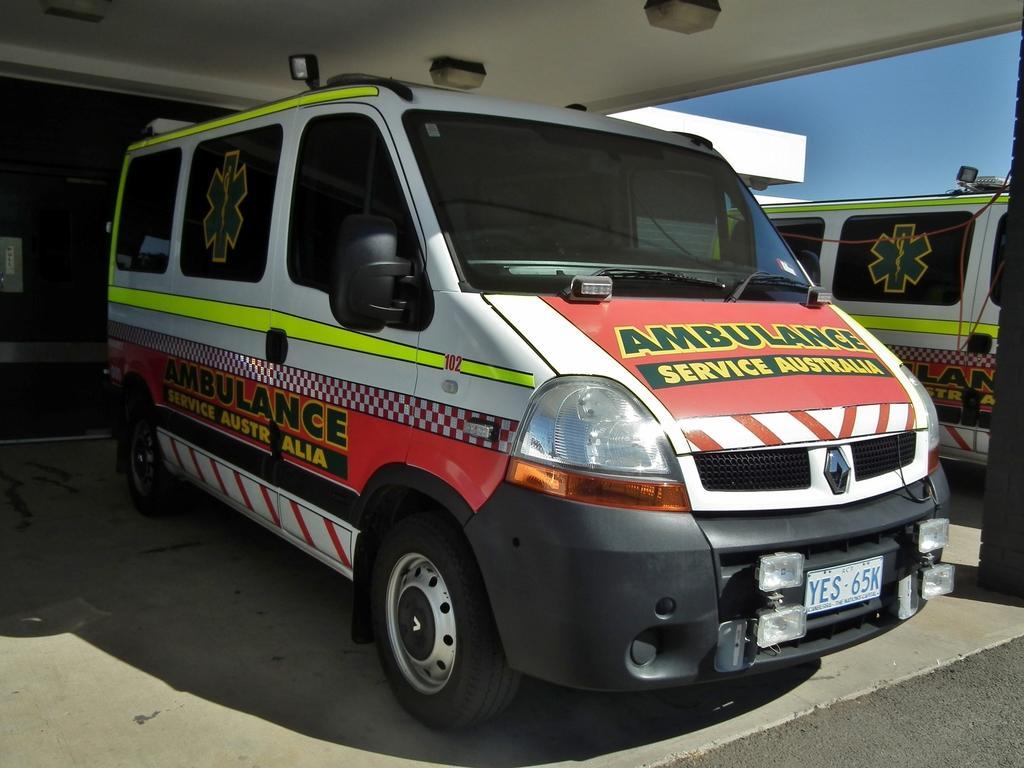In one or two sentences, can you explain what this image depicts? In this image in the center there are cars with some text written on it. In the background there is a building and on the top there are lights on the roof. 